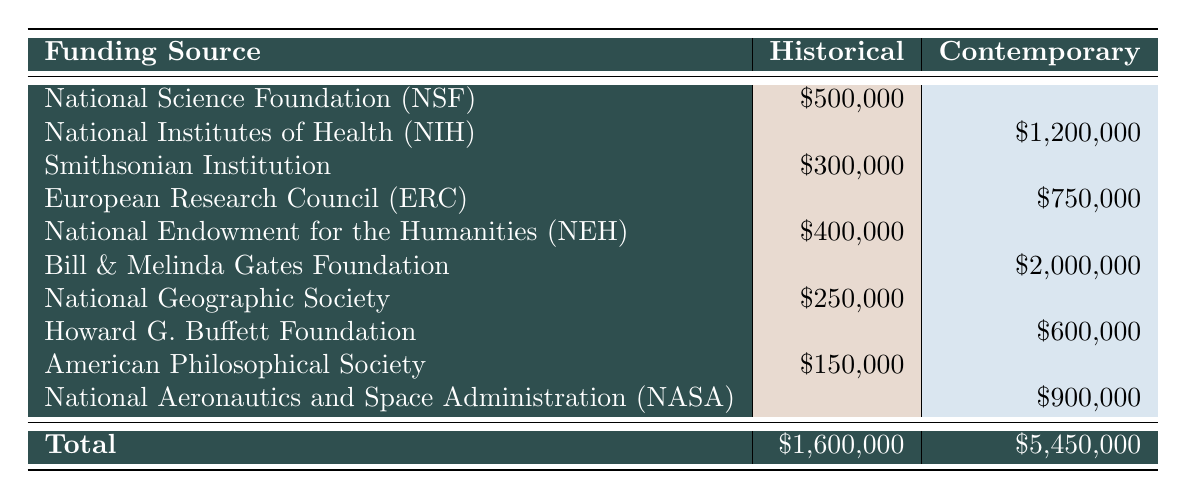What is the total funding amount for historical scientific studies? The total funding for historical scientific studies is calculated by summing the funding amounts for all historical entries: 500000 (NSF) + 300000 (Smithsonian) + 400000 (NEH) + 250000 (National Geographic) + 150000 (American Philosophical Society) = 1600000.
Answer: 1600000 Which contemporary funding source has the highest amount? By reviewing the funding amounts for contemporary studies, we see the following: 1200000 (NIH), 750000 (ERC), 2000000 (Bill & Melinda Gates), 600000 (Howard G. Buffett), and 900000 (NASA). The highest among these is 2000000 from the Bill & Melinda Gates Foundation.
Answer: Bill & Melinda Gates Foundation Is the total funding for contemporary studies greater than that for historical studies? The total funding for contemporary studies is 5450000, while for historical studies, it is 1600000. Since 5450000 is greater than 1600000, the answer is yes.
Answer: Yes What is the average funding amount for historical studies? To find the average, first we calculate the total funding amount for historical studies, which is 1600000 as found previously. There are 5 historical funding sources. So, the average is 1600000 / 5 = 320000.
Answer: 320000 Does the National Science Foundation provide funding for contemporary studies? In the table, the National Science Foundation (NSF) is listed only under the historical category and has no entry under contemporary studies. Therefore, the answer is no.
Answer: No What is the difference between the total funding for contemporary studies and the total funding for historical studies? The total for contemporary studies is 5450000 and for historical studies is 1600000. The difference can be calculated as 5450000 - 1600000 = 3850000.
Answer: 3850000 Which historical funding source has the smallest amount? Looking at the historical entries: 500000 (NSF), 300000 (Smithsonian), 400000 (NEH), 250000 (National Geographic), and 150000 (American Philosophical Society), we see that 150000 from the American Philosophical Society is the smallest.
Answer: American Philosophical Society How many funding sources are listed for contemporary scientific studies? There are 5 funding sources listed in the contemporary category: NIH, ERC, Bill & Melinda Gates, Howard G. Buffett, and NASA. Therefore, the total number is 5.
Answer: 5 